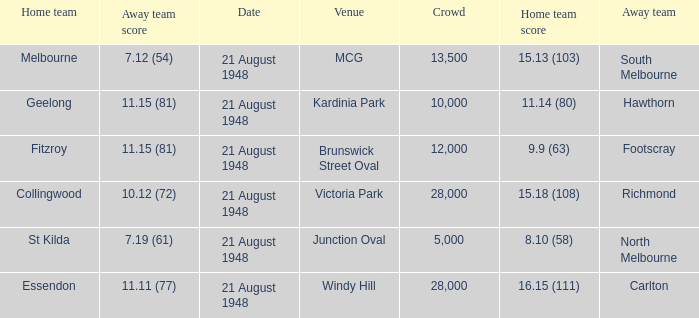When the venue is victoria park, what's the largest Crowd that attended? 28000.0. 